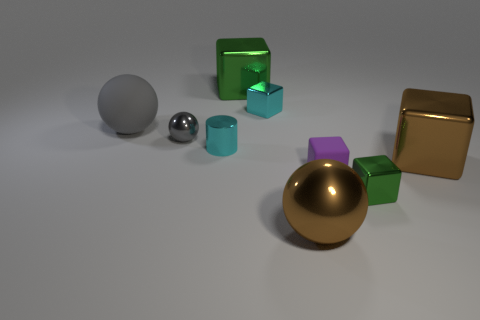How many gray balls must be subtracted to get 1 gray balls? 1 Subtract all tiny cyan metallic blocks. How many blocks are left? 4 Subtract all brown blocks. How many blocks are left? 4 Subtract all yellow cubes. Subtract all purple balls. How many cubes are left? 5 Subtract all cylinders. How many objects are left? 8 Add 2 large gray things. How many large gray things are left? 3 Add 4 cubes. How many cubes exist? 9 Subtract 0 blue cylinders. How many objects are left? 9 Subtract all tiny green shiny balls. Subtract all big green things. How many objects are left? 8 